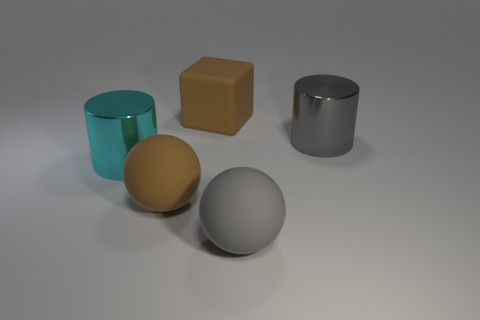Add 4 large gray spheres. How many objects exist? 9 Subtract all spheres. How many objects are left? 3 Add 2 big gray metal things. How many big gray metal things are left? 3 Add 1 big cyan metal cylinders. How many big cyan metal cylinders exist? 2 Subtract 1 brown cubes. How many objects are left? 4 Subtract all big purple rubber balls. Subtract all big cyan shiny things. How many objects are left? 4 